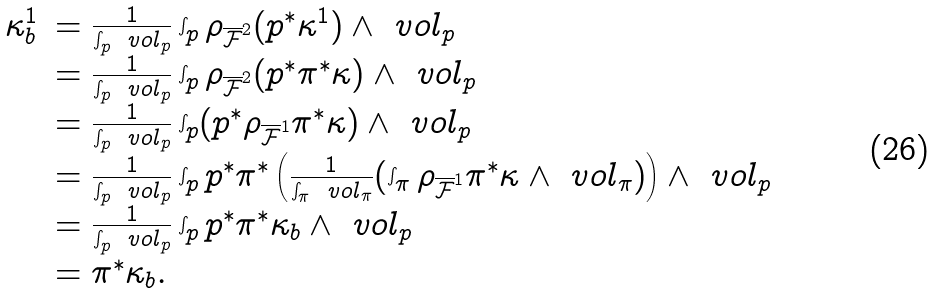<formula> <loc_0><loc_0><loc_500><loc_500>\begin{array} { r l } \kappa _ { b } ^ { 1 } & = \frac { 1 } { \int _ { p } \ v o l _ { p } } \int _ { p } \rho _ { \overline { \mathcal { F } } ^ { 2 } } ( p ^ { * } \kappa ^ { 1 } ) \wedge \ v o l _ { p } \\ & = \frac { 1 } { \int _ { p } \ v o l _ { p } } \int _ { p } \rho _ { \overline { \mathcal { F } } ^ { 2 } } ( p ^ { * } \pi ^ { * } \kappa ) \wedge \ v o l _ { p } \\ & = \frac { 1 } { \int _ { p } \ v o l _ { p } } \int _ { p } ( p ^ { * } \rho _ { \overline { \mathcal { F } } ^ { 1 } } \pi ^ { * } \kappa ) \wedge \ v o l _ { p } \\ & = \frac { 1 } { \int _ { p } \ v o l _ { p } } \int _ { p } p ^ { * } \pi ^ { * } \left ( \frac { 1 } { \int _ { \pi } \ v o l _ { \pi } } ( \int _ { \pi } \rho _ { \overline { \mathcal { F } } ^ { 1 } } \pi ^ { * } \kappa \wedge \ v o l _ { \pi } ) \right ) \wedge \ v o l _ { p } \\ & = \frac { 1 } { \int _ { p } \ v o l _ { p } } \int _ { p } p ^ { * } \pi ^ { * } \kappa _ { b } \wedge \ v o l _ { p } \\ & = \pi ^ { * } \kappa _ { b } . \end{array}</formula> 